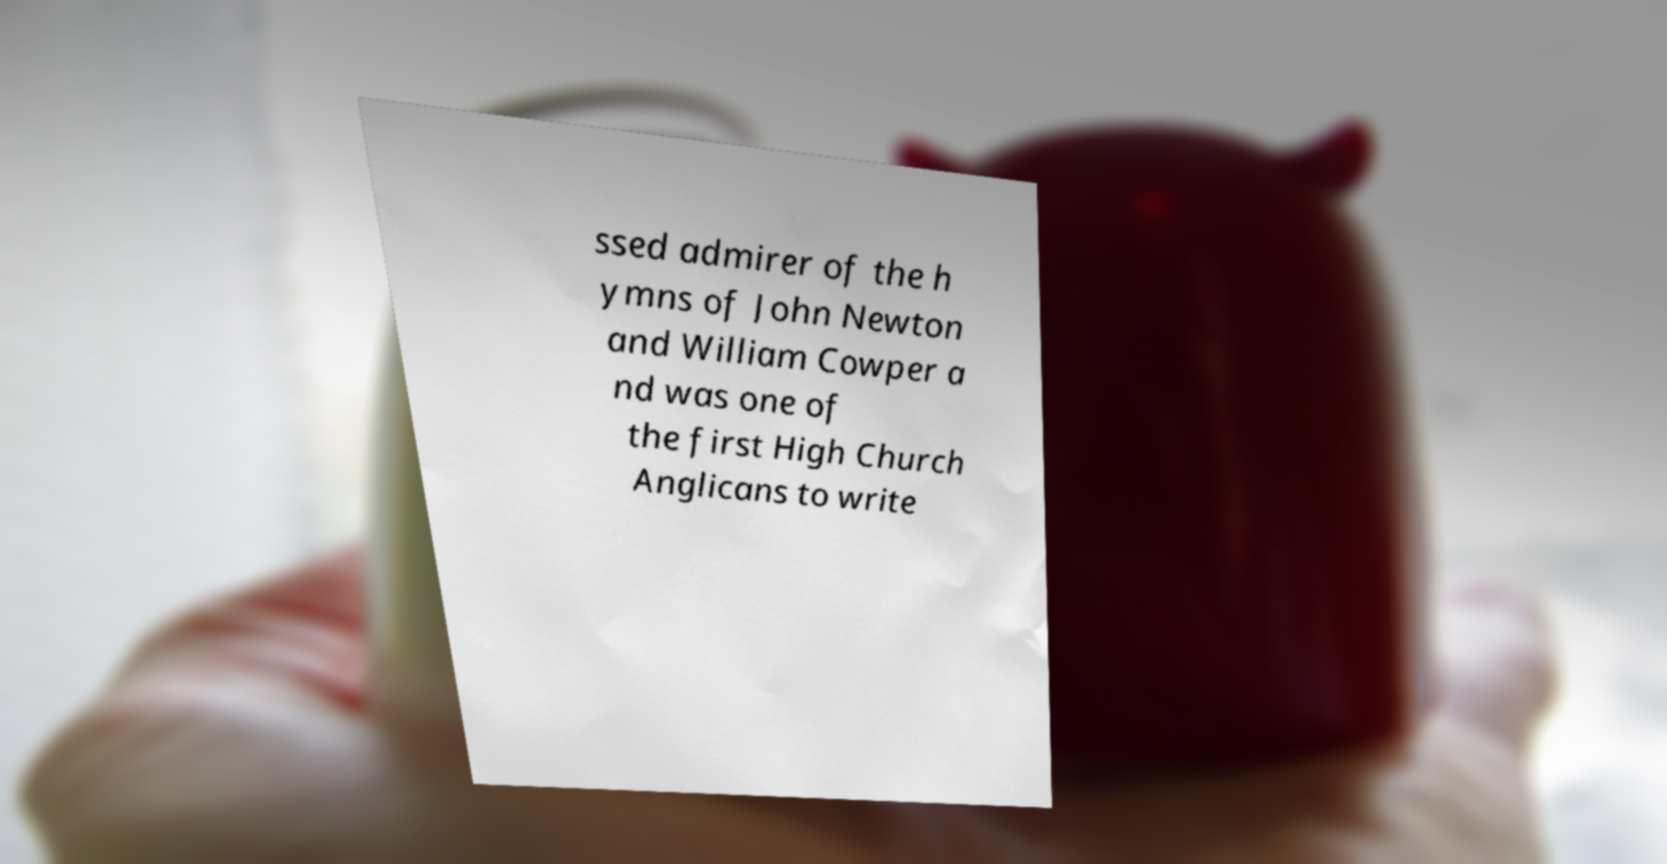Please read and relay the text visible in this image. What does it say? ssed admirer of the h ymns of John Newton and William Cowper a nd was one of the first High Church Anglicans to write 